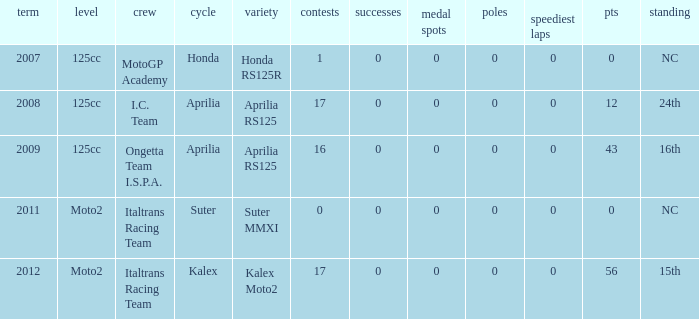What's the number of poles in the season where the team had a Kalex motorcycle? 0.0. 